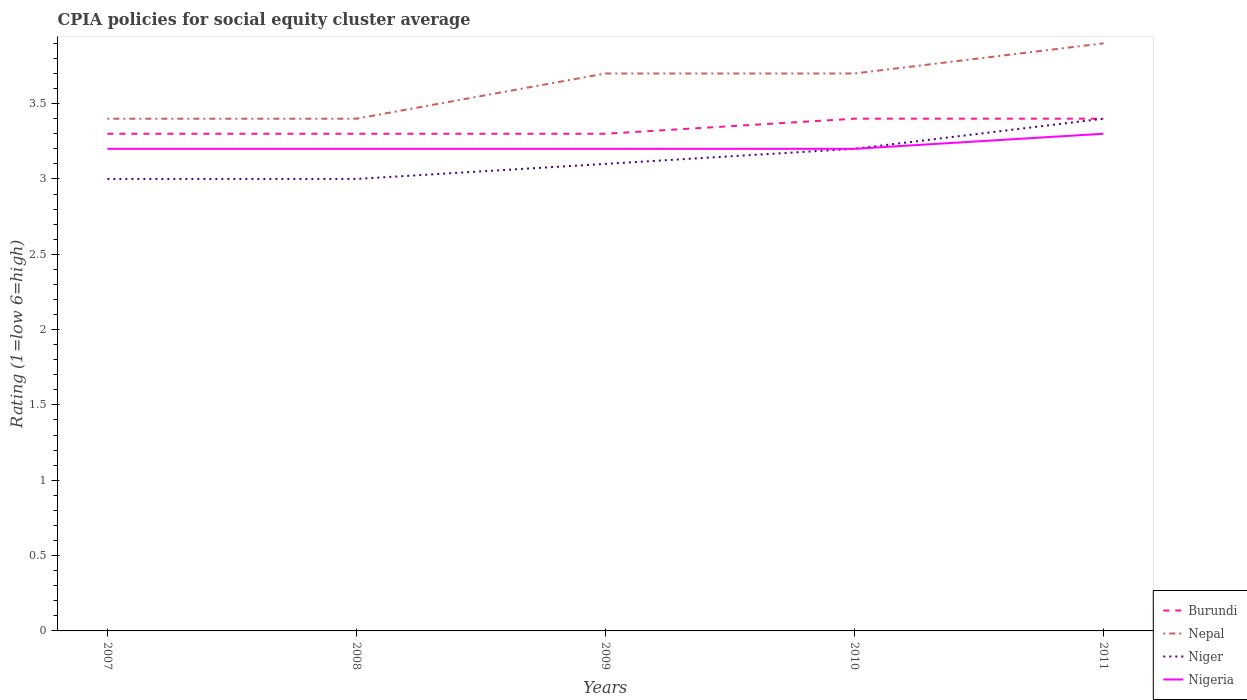How many different coloured lines are there?
Ensure brevity in your answer.  4. Is the number of lines equal to the number of legend labels?
Your answer should be very brief. Yes. Across all years, what is the maximum CPIA rating in Nigeria?
Your answer should be very brief. 3.2. What is the difference between the highest and the second highest CPIA rating in Nigeria?
Provide a succinct answer. 0.1. What is the difference between the highest and the lowest CPIA rating in Burundi?
Your answer should be compact. 2. How many lines are there?
Your answer should be compact. 4. How many years are there in the graph?
Make the answer very short. 5. What is the difference between two consecutive major ticks on the Y-axis?
Provide a short and direct response. 0.5. Are the values on the major ticks of Y-axis written in scientific E-notation?
Offer a terse response. No. Does the graph contain any zero values?
Ensure brevity in your answer.  No. Does the graph contain grids?
Ensure brevity in your answer.  No. Where does the legend appear in the graph?
Your response must be concise. Bottom right. How are the legend labels stacked?
Provide a short and direct response. Vertical. What is the title of the graph?
Give a very brief answer. CPIA policies for social equity cluster average. Does "Iceland" appear as one of the legend labels in the graph?
Provide a succinct answer. No. What is the label or title of the X-axis?
Provide a succinct answer. Years. What is the label or title of the Y-axis?
Provide a succinct answer. Rating (1=low 6=high). What is the Rating (1=low 6=high) in Nigeria in 2007?
Make the answer very short. 3.2. What is the Rating (1=low 6=high) of Nepal in 2009?
Your answer should be very brief. 3.7. What is the Rating (1=low 6=high) in Nigeria in 2010?
Keep it short and to the point. 3.2. Across all years, what is the maximum Rating (1=low 6=high) in Burundi?
Give a very brief answer. 3.4. Across all years, what is the maximum Rating (1=low 6=high) in Nigeria?
Ensure brevity in your answer.  3.3. Across all years, what is the minimum Rating (1=low 6=high) of Burundi?
Keep it short and to the point. 3.3. What is the total Rating (1=low 6=high) of Burundi in the graph?
Provide a short and direct response. 16.7. What is the total Rating (1=low 6=high) of Nepal in the graph?
Make the answer very short. 18.1. What is the total Rating (1=low 6=high) of Nigeria in the graph?
Offer a terse response. 16.1. What is the difference between the Rating (1=low 6=high) in Burundi in 2007 and that in 2008?
Your answer should be compact. 0. What is the difference between the Rating (1=low 6=high) of Nigeria in 2007 and that in 2008?
Offer a terse response. 0. What is the difference between the Rating (1=low 6=high) of Burundi in 2007 and that in 2009?
Provide a succinct answer. 0. What is the difference between the Rating (1=low 6=high) in Nepal in 2007 and that in 2009?
Provide a succinct answer. -0.3. What is the difference between the Rating (1=low 6=high) of Niger in 2007 and that in 2009?
Give a very brief answer. -0.1. What is the difference between the Rating (1=low 6=high) of Burundi in 2007 and that in 2010?
Ensure brevity in your answer.  -0.1. What is the difference between the Rating (1=low 6=high) of Niger in 2007 and that in 2010?
Keep it short and to the point. -0.2. What is the difference between the Rating (1=low 6=high) in Nigeria in 2007 and that in 2010?
Give a very brief answer. 0. What is the difference between the Rating (1=low 6=high) of Nepal in 2007 and that in 2011?
Keep it short and to the point. -0.5. What is the difference between the Rating (1=low 6=high) of Nepal in 2008 and that in 2009?
Your answer should be compact. -0.3. What is the difference between the Rating (1=low 6=high) of Niger in 2008 and that in 2009?
Offer a terse response. -0.1. What is the difference between the Rating (1=low 6=high) of Nigeria in 2008 and that in 2009?
Make the answer very short. 0. What is the difference between the Rating (1=low 6=high) in Niger in 2008 and that in 2010?
Offer a very short reply. -0.2. What is the difference between the Rating (1=low 6=high) of Niger in 2008 and that in 2011?
Keep it short and to the point. -0.4. What is the difference between the Rating (1=low 6=high) in Nepal in 2009 and that in 2010?
Your answer should be compact. 0. What is the difference between the Rating (1=low 6=high) of Burundi in 2009 and that in 2011?
Your answer should be very brief. -0.1. What is the difference between the Rating (1=low 6=high) in Nepal in 2009 and that in 2011?
Your answer should be very brief. -0.2. What is the difference between the Rating (1=low 6=high) of Nigeria in 2009 and that in 2011?
Provide a succinct answer. -0.1. What is the difference between the Rating (1=low 6=high) in Burundi in 2007 and the Rating (1=low 6=high) in Nepal in 2008?
Provide a succinct answer. -0.1. What is the difference between the Rating (1=low 6=high) of Niger in 2007 and the Rating (1=low 6=high) of Nigeria in 2008?
Keep it short and to the point. -0.2. What is the difference between the Rating (1=low 6=high) in Burundi in 2007 and the Rating (1=low 6=high) in Nigeria in 2009?
Offer a very short reply. 0.1. What is the difference between the Rating (1=low 6=high) in Niger in 2007 and the Rating (1=low 6=high) in Nigeria in 2009?
Your response must be concise. -0.2. What is the difference between the Rating (1=low 6=high) of Burundi in 2007 and the Rating (1=low 6=high) of Nepal in 2010?
Your answer should be compact. -0.4. What is the difference between the Rating (1=low 6=high) in Burundi in 2007 and the Rating (1=low 6=high) in Niger in 2010?
Provide a succinct answer. 0.1. What is the difference between the Rating (1=low 6=high) of Burundi in 2007 and the Rating (1=low 6=high) of Nigeria in 2010?
Give a very brief answer. 0.1. What is the difference between the Rating (1=low 6=high) of Niger in 2007 and the Rating (1=low 6=high) of Nigeria in 2010?
Offer a terse response. -0.2. What is the difference between the Rating (1=low 6=high) in Burundi in 2007 and the Rating (1=low 6=high) in Nepal in 2011?
Offer a terse response. -0.6. What is the difference between the Rating (1=low 6=high) in Nepal in 2007 and the Rating (1=low 6=high) in Niger in 2011?
Provide a succinct answer. 0. What is the difference between the Rating (1=low 6=high) in Nepal in 2007 and the Rating (1=low 6=high) in Nigeria in 2011?
Make the answer very short. 0.1. What is the difference between the Rating (1=low 6=high) in Niger in 2007 and the Rating (1=low 6=high) in Nigeria in 2011?
Your answer should be compact. -0.3. What is the difference between the Rating (1=low 6=high) of Burundi in 2008 and the Rating (1=low 6=high) of Nepal in 2009?
Your answer should be compact. -0.4. What is the difference between the Rating (1=low 6=high) in Burundi in 2008 and the Rating (1=low 6=high) in Niger in 2009?
Offer a terse response. 0.2. What is the difference between the Rating (1=low 6=high) of Burundi in 2008 and the Rating (1=low 6=high) of Nepal in 2010?
Your response must be concise. -0.4. What is the difference between the Rating (1=low 6=high) of Burundi in 2008 and the Rating (1=low 6=high) of Nigeria in 2010?
Your answer should be compact. 0.1. What is the difference between the Rating (1=low 6=high) of Nepal in 2008 and the Rating (1=low 6=high) of Nigeria in 2010?
Offer a terse response. 0.2. What is the difference between the Rating (1=low 6=high) of Niger in 2008 and the Rating (1=low 6=high) of Nigeria in 2010?
Your answer should be compact. -0.2. What is the difference between the Rating (1=low 6=high) of Burundi in 2008 and the Rating (1=low 6=high) of Nepal in 2011?
Your response must be concise. -0.6. What is the difference between the Rating (1=low 6=high) of Nepal in 2008 and the Rating (1=low 6=high) of Niger in 2011?
Provide a short and direct response. 0. What is the difference between the Rating (1=low 6=high) of Niger in 2008 and the Rating (1=low 6=high) of Nigeria in 2011?
Offer a very short reply. -0.3. What is the difference between the Rating (1=low 6=high) of Burundi in 2009 and the Rating (1=low 6=high) of Nigeria in 2010?
Provide a short and direct response. 0.1. What is the difference between the Rating (1=low 6=high) of Nepal in 2009 and the Rating (1=low 6=high) of Niger in 2010?
Give a very brief answer. 0.5. What is the difference between the Rating (1=low 6=high) in Nepal in 2009 and the Rating (1=low 6=high) in Nigeria in 2010?
Your answer should be very brief. 0.5. What is the difference between the Rating (1=low 6=high) in Burundi in 2009 and the Rating (1=low 6=high) in Nepal in 2011?
Offer a terse response. -0.6. What is the difference between the Rating (1=low 6=high) of Burundi in 2009 and the Rating (1=low 6=high) of Niger in 2011?
Make the answer very short. -0.1. What is the difference between the Rating (1=low 6=high) of Niger in 2009 and the Rating (1=low 6=high) of Nigeria in 2011?
Your response must be concise. -0.2. What is the difference between the Rating (1=low 6=high) in Burundi in 2010 and the Rating (1=low 6=high) in Nepal in 2011?
Give a very brief answer. -0.5. What is the difference between the Rating (1=low 6=high) of Burundi in 2010 and the Rating (1=low 6=high) of Niger in 2011?
Ensure brevity in your answer.  0. What is the difference between the Rating (1=low 6=high) of Niger in 2010 and the Rating (1=low 6=high) of Nigeria in 2011?
Give a very brief answer. -0.1. What is the average Rating (1=low 6=high) of Burundi per year?
Make the answer very short. 3.34. What is the average Rating (1=low 6=high) in Nepal per year?
Offer a terse response. 3.62. What is the average Rating (1=low 6=high) in Niger per year?
Give a very brief answer. 3.14. What is the average Rating (1=low 6=high) of Nigeria per year?
Your answer should be compact. 3.22. In the year 2007, what is the difference between the Rating (1=low 6=high) of Burundi and Rating (1=low 6=high) of Nepal?
Keep it short and to the point. -0.1. In the year 2007, what is the difference between the Rating (1=low 6=high) of Burundi and Rating (1=low 6=high) of Niger?
Offer a terse response. 0.3. In the year 2008, what is the difference between the Rating (1=low 6=high) in Burundi and Rating (1=low 6=high) in Nepal?
Your response must be concise. -0.1. In the year 2008, what is the difference between the Rating (1=low 6=high) in Nepal and Rating (1=low 6=high) in Niger?
Your answer should be compact. 0.4. In the year 2008, what is the difference between the Rating (1=low 6=high) of Niger and Rating (1=low 6=high) of Nigeria?
Make the answer very short. -0.2. In the year 2009, what is the difference between the Rating (1=low 6=high) of Burundi and Rating (1=low 6=high) of Nepal?
Provide a succinct answer. -0.4. In the year 2009, what is the difference between the Rating (1=low 6=high) in Burundi and Rating (1=low 6=high) in Nigeria?
Your answer should be compact. 0.1. In the year 2009, what is the difference between the Rating (1=low 6=high) in Nepal and Rating (1=low 6=high) in Nigeria?
Ensure brevity in your answer.  0.5. In the year 2010, what is the difference between the Rating (1=low 6=high) of Burundi and Rating (1=low 6=high) of Niger?
Make the answer very short. 0.2. In the year 2010, what is the difference between the Rating (1=low 6=high) in Burundi and Rating (1=low 6=high) in Nigeria?
Provide a short and direct response. 0.2. In the year 2010, what is the difference between the Rating (1=low 6=high) of Nepal and Rating (1=low 6=high) of Nigeria?
Provide a short and direct response. 0.5. In the year 2011, what is the difference between the Rating (1=low 6=high) of Burundi and Rating (1=low 6=high) of Niger?
Keep it short and to the point. 0. In the year 2011, what is the difference between the Rating (1=low 6=high) in Nepal and Rating (1=low 6=high) in Niger?
Provide a short and direct response. 0.5. In the year 2011, what is the difference between the Rating (1=low 6=high) of Nepal and Rating (1=low 6=high) of Nigeria?
Offer a terse response. 0.6. What is the ratio of the Rating (1=low 6=high) of Niger in 2007 to that in 2008?
Offer a very short reply. 1. What is the ratio of the Rating (1=low 6=high) of Burundi in 2007 to that in 2009?
Ensure brevity in your answer.  1. What is the ratio of the Rating (1=low 6=high) in Nepal in 2007 to that in 2009?
Ensure brevity in your answer.  0.92. What is the ratio of the Rating (1=low 6=high) in Niger in 2007 to that in 2009?
Give a very brief answer. 0.97. What is the ratio of the Rating (1=low 6=high) of Nigeria in 2007 to that in 2009?
Ensure brevity in your answer.  1. What is the ratio of the Rating (1=low 6=high) of Burundi in 2007 to that in 2010?
Ensure brevity in your answer.  0.97. What is the ratio of the Rating (1=low 6=high) of Nepal in 2007 to that in 2010?
Give a very brief answer. 0.92. What is the ratio of the Rating (1=low 6=high) in Niger in 2007 to that in 2010?
Provide a short and direct response. 0.94. What is the ratio of the Rating (1=low 6=high) in Nigeria in 2007 to that in 2010?
Make the answer very short. 1. What is the ratio of the Rating (1=low 6=high) of Burundi in 2007 to that in 2011?
Provide a short and direct response. 0.97. What is the ratio of the Rating (1=low 6=high) of Nepal in 2007 to that in 2011?
Offer a very short reply. 0.87. What is the ratio of the Rating (1=low 6=high) in Niger in 2007 to that in 2011?
Ensure brevity in your answer.  0.88. What is the ratio of the Rating (1=low 6=high) of Nigeria in 2007 to that in 2011?
Provide a succinct answer. 0.97. What is the ratio of the Rating (1=low 6=high) of Burundi in 2008 to that in 2009?
Make the answer very short. 1. What is the ratio of the Rating (1=low 6=high) of Nepal in 2008 to that in 2009?
Offer a very short reply. 0.92. What is the ratio of the Rating (1=low 6=high) in Niger in 2008 to that in 2009?
Offer a very short reply. 0.97. What is the ratio of the Rating (1=low 6=high) in Nigeria in 2008 to that in 2009?
Your answer should be compact. 1. What is the ratio of the Rating (1=low 6=high) in Burundi in 2008 to that in 2010?
Provide a short and direct response. 0.97. What is the ratio of the Rating (1=low 6=high) of Nepal in 2008 to that in 2010?
Your answer should be very brief. 0.92. What is the ratio of the Rating (1=low 6=high) in Niger in 2008 to that in 2010?
Offer a very short reply. 0.94. What is the ratio of the Rating (1=low 6=high) in Nigeria in 2008 to that in 2010?
Your answer should be very brief. 1. What is the ratio of the Rating (1=low 6=high) in Burundi in 2008 to that in 2011?
Provide a succinct answer. 0.97. What is the ratio of the Rating (1=low 6=high) in Nepal in 2008 to that in 2011?
Give a very brief answer. 0.87. What is the ratio of the Rating (1=low 6=high) of Niger in 2008 to that in 2011?
Offer a very short reply. 0.88. What is the ratio of the Rating (1=low 6=high) in Nigeria in 2008 to that in 2011?
Keep it short and to the point. 0.97. What is the ratio of the Rating (1=low 6=high) of Burundi in 2009 to that in 2010?
Provide a short and direct response. 0.97. What is the ratio of the Rating (1=low 6=high) of Nepal in 2009 to that in 2010?
Make the answer very short. 1. What is the ratio of the Rating (1=low 6=high) in Niger in 2009 to that in 2010?
Make the answer very short. 0.97. What is the ratio of the Rating (1=low 6=high) of Burundi in 2009 to that in 2011?
Provide a short and direct response. 0.97. What is the ratio of the Rating (1=low 6=high) of Nepal in 2009 to that in 2011?
Your response must be concise. 0.95. What is the ratio of the Rating (1=low 6=high) in Niger in 2009 to that in 2011?
Offer a very short reply. 0.91. What is the ratio of the Rating (1=low 6=high) of Nigeria in 2009 to that in 2011?
Provide a short and direct response. 0.97. What is the ratio of the Rating (1=low 6=high) in Burundi in 2010 to that in 2011?
Your answer should be very brief. 1. What is the ratio of the Rating (1=low 6=high) of Nepal in 2010 to that in 2011?
Ensure brevity in your answer.  0.95. What is the ratio of the Rating (1=low 6=high) of Niger in 2010 to that in 2011?
Provide a short and direct response. 0.94. What is the ratio of the Rating (1=low 6=high) of Nigeria in 2010 to that in 2011?
Keep it short and to the point. 0.97. What is the difference between the highest and the second highest Rating (1=low 6=high) of Burundi?
Your response must be concise. 0. What is the difference between the highest and the second highest Rating (1=low 6=high) in Niger?
Your response must be concise. 0.2. What is the difference between the highest and the lowest Rating (1=low 6=high) of Burundi?
Your response must be concise. 0.1. What is the difference between the highest and the lowest Rating (1=low 6=high) of Nigeria?
Make the answer very short. 0.1. 